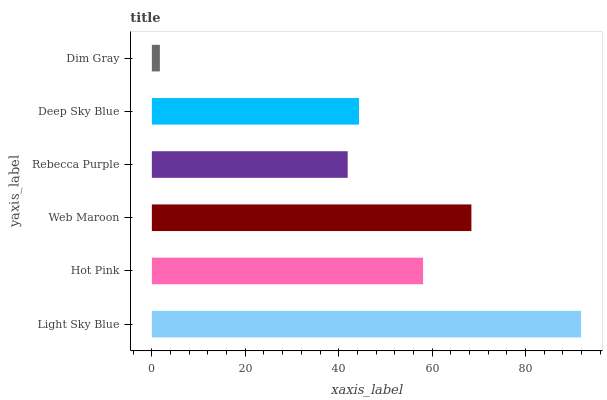Is Dim Gray the minimum?
Answer yes or no. Yes. Is Light Sky Blue the maximum?
Answer yes or no. Yes. Is Hot Pink the minimum?
Answer yes or no. No. Is Hot Pink the maximum?
Answer yes or no. No. Is Light Sky Blue greater than Hot Pink?
Answer yes or no. Yes. Is Hot Pink less than Light Sky Blue?
Answer yes or no. Yes. Is Hot Pink greater than Light Sky Blue?
Answer yes or no. No. Is Light Sky Blue less than Hot Pink?
Answer yes or no. No. Is Hot Pink the high median?
Answer yes or no. Yes. Is Deep Sky Blue the low median?
Answer yes or no. Yes. Is Rebecca Purple the high median?
Answer yes or no. No. Is Dim Gray the low median?
Answer yes or no. No. 